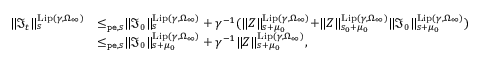Convert formula to latex. <formula><loc_0><loc_0><loc_500><loc_500>\begin{array} { r l } { \| \mathfrak { I } _ { t } \| _ { s } ^ { L i p ( \gamma , \Omega _ { \infty } ) } } & { \leq _ { p e , s } \| \mathfrak { I } _ { 0 } \| _ { s } ^ { L i p ( \gamma , \Omega _ { \infty } ) } + \gamma ^ { - 1 } ( \| Z \| _ { s + \mu _ { 0 } } ^ { L i p ( \gamma , \Omega _ { \infty } ) } + \| Z \| _ { s _ { 0 } + \mu _ { 0 } } ^ { L i p ( \gamma , \Omega _ { \infty } ) } \| \mathfrak { I } _ { 0 } \| _ { s + \mu _ { 0 } } ^ { L i p ( \gamma , \Omega _ { \infty } ) } ) } \\ & { \leq _ { p e , s } \| \mathfrak { I } _ { 0 } \| _ { s + \mu _ { 0 } } ^ { L i p ( \gamma , \Omega _ { \infty } ) } + \gamma ^ { - 1 } \| Z \| _ { s + \mu _ { 0 } } ^ { L i p ( \gamma , \Omega _ { \infty } ) } , } \end{array}</formula> 